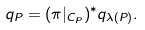<formula> <loc_0><loc_0><loc_500><loc_500>q _ { P } = ( \pi | _ { C _ { P } } ) ^ { * } q _ { \lambda ( P ) } .</formula> 